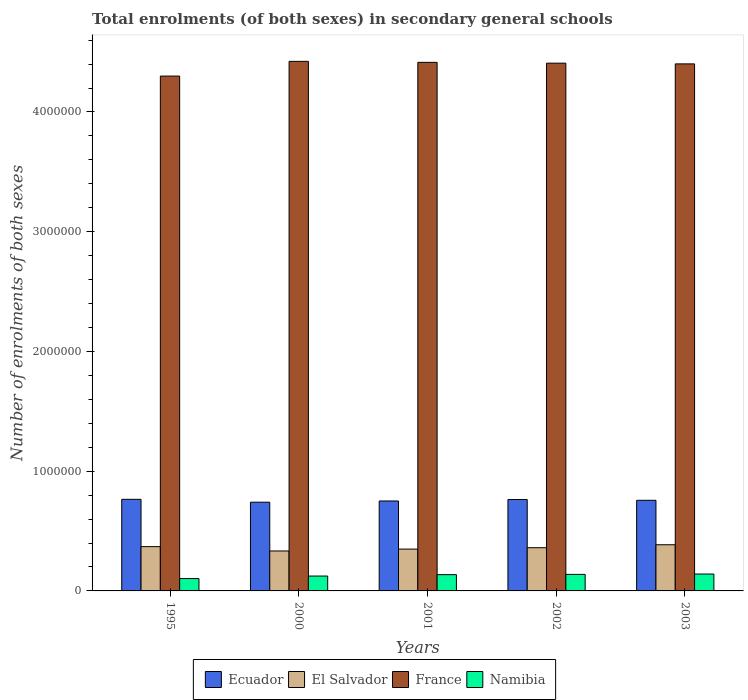How many groups of bars are there?
Ensure brevity in your answer.  5. Are the number of bars per tick equal to the number of legend labels?
Your answer should be very brief. Yes. Are the number of bars on each tick of the X-axis equal?
Provide a succinct answer. Yes. What is the label of the 5th group of bars from the left?
Make the answer very short. 2003. In how many cases, is the number of bars for a given year not equal to the number of legend labels?
Make the answer very short. 0. What is the number of enrolments in secondary schools in Namibia in 1995?
Keep it short and to the point. 1.03e+05. Across all years, what is the maximum number of enrolments in secondary schools in France?
Your answer should be compact. 4.42e+06. Across all years, what is the minimum number of enrolments in secondary schools in Namibia?
Give a very brief answer. 1.03e+05. What is the total number of enrolments in secondary schools in France in the graph?
Your answer should be compact. 2.19e+07. What is the difference between the number of enrolments in secondary schools in Ecuador in 1995 and that in 2003?
Provide a short and direct response. 8229. What is the difference between the number of enrolments in secondary schools in France in 2000 and the number of enrolments in secondary schools in Namibia in 2002?
Provide a succinct answer. 4.28e+06. What is the average number of enrolments in secondary schools in El Salvador per year?
Offer a terse response. 3.60e+05. In the year 1995, what is the difference between the number of enrolments in secondary schools in El Salvador and number of enrolments in secondary schools in Ecuador?
Ensure brevity in your answer.  -3.95e+05. In how many years, is the number of enrolments in secondary schools in El Salvador greater than 800000?
Offer a very short reply. 0. What is the ratio of the number of enrolments in secondary schools in France in 1995 to that in 2002?
Keep it short and to the point. 0.98. Is the number of enrolments in secondary schools in El Salvador in 1995 less than that in 2003?
Ensure brevity in your answer.  Yes. Is the difference between the number of enrolments in secondary schools in El Salvador in 1995 and 2000 greater than the difference between the number of enrolments in secondary schools in Ecuador in 1995 and 2000?
Offer a terse response. Yes. What is the difference between the highest and the second highest number of enrolments in secondary schools in El Salvador?
Give a very brief answer. 1.57e+04. What is the difference between the highest and the lowest number of enrolments in secondary schools in Ecuador?
Your answer should be compact. 2.40e+04. Is the sum of the number of enrolments in secondary schools in Namibia in 2000 and 2003 greater than the maximum number of enrolments in secondary schools in France across all years?
Make the answer very short. No. What does the 3rd bar from the left in 2002 represents?
Your response must be concise. France. What does the 4th bar from the right in 1995 represents?
Offer a very short reply. Ecuador. How many bars are there?
Keep it short and to the point. 20. How many years are there in the graph?
Provide a succinct answer. 5. What is the difference between two consecutive major ticks on the Y-axis?
Provide a succinct answer. 1.00e+06. Are the values on the major ticks of Y-axis written in scientific E-notation?
Offer a very short reply. No. Does the graph contain any zero values?
Your response must be concise. No. Does the graph contain grids?
Offer a terse response. No. What is the title of the graph?
Provide a short and direct response. Total enrolments (of both sexes) in secondary general schools. Does "Mauritania" appear as one of the legend labels in the graph?
Provide a succinct answer. No. What is the label or title of the Y-axis?
Offer a very short reply. Number of enrolments of both sexes. What is the Number of enrolments of both sexes of Ecuador in 1995?
Make the answer very short. 7.65e+05. What is the Number of enrolments of both sexes of El Salvador in 1995?
Offer a very short reply. 3.70e+05. What is the Number of enrolments of both sexes in France in 1995?
Your response must be concise. 4.30e+06. What is the Number of enrolments of both sexes in Namibia in 1995?
Give a very brief answer. 1.03e+05. What is the Number of enrolments of both sexes in Ecuador in 2000?
Provide a short and direct response. 7.41e+05. What is the Number of enrolments of both sexes of El Salvador in 2000?
Offer a terse response. 3.34e+05. What is the Number of enrolments of both sexes of France in 2000?
Provide a short and direct response. 4.42e+06. What is the Number of enrolments of both sexes in Namibia in 2000?
Keep it short and to the point. 1.24e+05. What is the Number of enrolments of both sexes in Ecuador in 2001?
Ensure brevity in your answer.  7.51e+05. What is the Number of enrolments of both sexes in El Salvador in 2001?
Provide a short and direct response. 3.49e+05. What is the Number of enrolments of both sexes in France in 2001?
Ensure brevity in your answer.  4.41e+06. What is the Number of enrolments of both sexes of Namibia in 2001?
Your answer should be compact. 1.36e+05. What is the Number of enrolments of both sexes of Ecuador in 2002?
Your response must be concise. 7.63e+05. What is the Number of enrolments of both sexes of El Salvador in 2002?
Make the answer very short. 3.61e+05. What is the Number of enrolments of both sexes in France in 2002?
Keep it short and to the point. 4.41e+06. What is the Number of enrolments of both sexes of Namibia in 2002?
Your answer should be very brief. 1.38e+05. What is the Number of enrolments of both sexes in Ecuador in 2003?
Give a very brief answer. 7.57e+05. What is the Number of enrolments of both sexes of El Salvador in 2003?
Make the answer very short. 3.86e+05. What is the Number of enrolments of both sexes in France in 2003?
Give a very brief answer. 4.40e+06. What is the Number of enrolments of both sexes in Namibia in 2003?
Keep it short and to the point. 1.41e+05. Across all years, what is the maximum Number of enrolments of both sexes of Ecuador?
Your response must be concise. 7.65e+05. Across all years, what is the maximum Number of enrolments of both sexes of El Salvador?
Offer a terse response. 3.86e+05. Across all years, what is the maximum Number of enrolments of both sexes of France?
Make the answer very short. 4.42e+06. Across all years, what is the maximum Number of enrolments of both sexes in Namibia?
Keep it short and to the point. 1.41e+05. Across all years, what is the minimum Number of enrolments of both sexes in Ecuador?
Your answer should be very brief. 7.41e+05. Across all years, what is the minimum Number of enrolments of both sexes of El Salvador?
Provide a short and direct response. 3.34e+05. Across all years, what is the minimum Number of enrolments of both sexes in France?
Your answer should be compact. 4.30e+06. Across all years, what is the minimum Number of enrolments of both sexes of Namibia?
Keep it short and to the point. 1.03e+05. What is the total Number of enrolments of both sexes in Ecuador in the graph?
Your answer should be compact. 3.78e+06. What is the total Number of enrolments of both sexes of El Salvador in the graph?
Make the answer very short. 1.80e+06. What is the total Number of enrolments of both sexes of France in the graph?
Offer a terse response. 2.19e+07. What is the total Number of enrolments of both sexes of Namibia in the graph?
Provide a succinct answer. 6.42e+05. What is the difference between the Number of enrolments of both sexes in Ecuador in 1995 and that in 2000?
Ensure brevity in your answer.  2.40e+04. What is the difference between the Number of enrolments of both sexes of El Salvador in 1995 and that in 2000?
Offer a terse response. 3.62e+04. What is the difference between the Number of enrolments of both sexes of France in 1995 and that in 2000?
Give a very brief answer. -1.23e+05. What is the difference between the Number of enrolments of both sexes in Namibia in 1995 and that in 2000?
Your answer should be compact. -2.10e+04. What is the difference between the Number of enrolments of both sexes of Ecuador in 1995 and that in 2001?
Make the answer very short. 1.38e+04. What is the difference between the Number of enrolments of both sexes in El Salvador in 1995 and that in 2001?
Keep it short and to the point. 2.05e+04. What is the difference between the Number of enrolments of both sexes of France in 1995 and that in 2001?
Offer a terse response. -1.15e+05. What is the difference between the Number of enrolments of both sexes in Namibia in 1995 and that in 2001?
Ensure brevity in your answer.  -3.27e+04. What is the difference between the Number of enrolments of both sexes of Ecuador in 1995 and that in 2002?
Provide a succinct answer. 1890. What is the difference between the Number of enrolments of both sexes of El Salvador in 1995 and that in 2002?
Offer a very short reply. 8955. What is the difference between the Number of enrolments of both sexes of France in 1995 and that in 2002?
Your answer should be very brief. -1.08e+05. What is the difference between the Number of enrolments of both sexes of Namibia in 1995 and that in 2002?
Offer a terse response. -3.49e+04. What is the difference between the Number of enrolments of both sexes of Ecuador in 1995 and that in 2003?
Your answer should be very brief. 8229. What is the difference between the Number of enrolments of both sexes in El Salvador in 1995 and that in 2003?
Offer a very short reply. -1.57e+04. What is the difference between the Number of enrolments of both sexes in France in 1995 and that in 2003?
Keep it short and to the point. -1.02e+05. What is the difference between the Number of enrolments of both sexes in Namibia in 1995 and that in 2003?
Give a very brief answer. -3.78e+04. What is the difference between the Number of enrolments of both sexes of Ecuador in 2000 and that in 2001?
Ensure brevity in your answer.  -1.02e+04. What is the difference between the Number of enrolments of both sexes of El Salvador in 2000 and that in 2001?
Provide a short and direct response. -1.57e+04. What is the difference between the Number of enrolments of both sexes of France in 2000 and that in 2001?
Make the answer very short. 8307. What is the difference between the Number of enrolments of both sexes in Namibia in 2000 and that in 2001?
Your answer should be very brief. -1.17e+04. What is the difference between the Number of enrolments of both sexes of Ecuador in 2000 and that in 2002?
Your answer should be very brief. -2.21e+04. What is the difference between the Number of enrolments of both sexes of El Salvador in 2000 and that in 2002?
Your response must be concise. -2.72e+04. What is the difference between the Number of enrolments of both sexes in France in 2000 and that in 2002?
Your response must be concise. 1.52e+04. What is the difference between the Number of enrolments of both sexes of Namibia in 2000 and that in 2002?
Make the answer very short. -1.39e+04. What is the difference between the Number of enrolments of both sexes of Ecuador in 2000 and that in 2003?
Make the answer very short. -1.58e+04. What is the difference between the Number of enrolments of both sexes in El Salvador in 2000 and that in 2003?
Provide a short and direct response. -5.19e+04. What is the difference between the Number of enrolments of both sexes in France in 2000 and that in 2003?
Your response must be concise. 2.11e+04. What is the difference between the Number of enrolments of both sexes in Namibia in 2000 and that in 2003?
Your answer should be very brief. -1.68e+04. What is the difference between the Number of enrolments of both sexes in Ecuador in 2001 and that in 2002?
Make the answer very short. -1.19e+04. What is the difference between the Number of enrolments of both sexes in El Salvador in 2001 and that in 2002?
Your response must be concise. -1.15e+04. What is the difference between the Number of enrolments of both sexes in France in 2001 and that in 2002?
Provide a short and direct response. 6854. What is the difference between the Number of enrolments of both sexes of Namibia in 2001 and that in 2002?
Provide a succinct answer. -2156. What is the difference between the Number of enrolments of both sexes of Ecuador in 2001 and that in 2003?
Your answer should be compact. -5604. What is the difference between the Number of enrolments of both sexes in El Salvador in 2001 and that in 2003?
Give a very brief answer. -3.62e+04. What is the difference between the Number of enrolments of both sexes of France in 2001 and that in 2003?
Keep it short and to the point. 1.28e+04. What is the difference between the Number of enrolments of both sexes in Namibia in 2001 and that in 2003?
Ensure brevity in your answer.  -5033. What is the difference between the Number of enrolments of both sexes in Ecuador in 2002 and that in 2003?
Keep it short and to the point. 6339. What is the difference between the Number of enrolments of both sexes of El Salvador in 2002 and that in 2003?
Your response must be concise. -2.46e+04. What is the difference between the Number of enrolments of both sexes in France in 2002 and that in 2003?
Give a very brief answer. 5914. What is the difference between the Number of enrolments of both sexes of Namibia in 2002 and that in 2003?
Provide a succinct answer. -2877. What is the difference between the Number of enrolments of both sexes in Ecuador in 1995 and the Number of enrolments of both sexes in El Salvador in 2000?
Provide a succinct answer. 4.31e+05. What is the difference between the Number of enrolments of both sexes in Ecuador in 1995 and the Number of enrolments of both sexes in France in 2000?
Offer a terse response. -3.66e+06. What is the difference between the Number of enrolments of both sexes in Ecuador in 1995 and the Number of enrolments of both sexes in Namibia in 2000?
Keep it short and to the point. 6.41e+05. What is the difference between the Number of enrolments of both sexes of El Salvador in 1995 and the Number of enrolments of both sexes of France in 2000?
Make the answer very short. -4.05e+06. What is the difference between the Number of enrolments of both sexes in El Salvador in 1995 and the Number of enrolments of both sexes in Namibia in 2000?
Ensure brevity in your answer.  2.46e+05. What is the difference between the Number of enrolments of both sexes of France in 1995 and the Number of enrolments of both sexes of Namibia in 2000?
Give a very brief answer. 4.18e+06. What is the difference between the Number of enrolments of both sexes in Ecuador in 1995 and the Number of enrolments of both sexes in El Salvador in 2001?
Make the answer very short. 4.16e+05. What is the difference between the Number of enrolments of both sexes in Ecuador in 1995 and the Number of enrolments of both sexes in France in 2001?
Give a very brief answer. -3.65e+06. What is the difference between the Number of enrolments of both sexes of Ecuador in 1995 and the Number of enrolments of both sexes of Namibia in 2001?
Ensure brevity in your answer.  6.29e+05. What is the difference between the Number of enrolments of both sexes in El Salvador in 1995 and the Number of enrolments of both sexes in France in 2001?
Provide a short and direct response. -4.04e+06. What is the difference between the Number of enrolments of both sexes in El Salvador in 1995 and the Number of enrolments of both sexes in Namibia in 2001?
Provide a succinct answer. 2.34e+05. What is the difference between the Number of enrolments of both sexes of France in 1995 and the Number of enrolments of both sexes of Namibia in 2001?
Your answer should be very brief. 4.16e+06. What is the difference between the Number of enrolments of both sexes in Ecuador in 1995 and the Number of enrolments of both sexes in El Salvador in 2002?
Your answer should be compact. 4.04e+05. What is the difference between the Number of enrolments of both sexes in Ecuador in 1995 and the Number of enrolments of both sexes in France in 2002?
Provide a succinct answer. -3.64e+06. What is the difference between the Number of enrolments of both sexes of Ecuador in 1995 and the Number of enrolments of both sexes of Namibia in 2002?
Offer a very short reply. 6.27e+05. What is the difference between the Number of enrolments of both sexes of El Salvador in 1995 and the Number of enrolments of both sexes of France in 2002?
Keep it short and to the point. -4.04e+06. What is the difference between the Number of enrolments of both sexes of El Salvador in 1995 and the Number of enrolments of both sexes of Namibia in 2002?
Your answer should be very brief. 2.32e+05. What is the difference between the Number of enrolments of both sexes in France in 1995 and the Number of enrolments of both sexes in Namibia in 2002?
Your answer should be very brief. 4.16e+06. What is the difference between the Number of enrolments of both sexes of Ecuador in 1995 and the Number of enrolments of both sexes of El Salvador in 2003?
Offer a terse response. 3.80e+05. What is the difference between the Number of enrolments of both sexes in Ecuador in 1995 and the Number of enrolments of both sexes in France in 2003?
Give a very brief answer. -3.64e+06. What is the difference between the Number of enrolments of both sexes in Ecuador in 1995 and the Number of enrolments of both sexes in Namibia in 2003?
Your answer should be compact. 6.24e+05. What is the difference between the Number of enrolments of both sexes of El Salvador in 1995 and the Number of enrolments of both sexes of France in 2003?
Give a very brief answer. -4.03e+06. What is the difference between the Number of enrolments of both sexes of El Salvador in 1995 and the Number of enrolments of both sexes of Namibia in 2003?
Your answer should be very brief. 2.29e+05. What is the difference between the Number of enrolments of both sexes of France in 1995 and the Number of enrolments of both sexes of Namibia in 2003?
Provide a succinct answer. 4.16e+06. What is the difference between the Number of enrolments of both sexes of Ecuador in 2000 and the Number of enrolments of both sexes of El Salvador in 2001?
Offer a very short reply. 3.92e+05. What is the difference between the Number of enrolments of both sexes in Ecuador in 2000 and the Number of enrolments of both sexes in France in 2001?
Your response must be concise. -3.67e+06. What is the difference between the Number of enrolments of both sexes in Ecuador in 2000 and the Number of enrolments of both sexes in Namibia in 2001?
Provide a short and direct response. 6.05e+05. What is the difference between the Number of enrolments of both sexes of El Salvador in 2000 and the Number of enrolments of both sexes of France in 2001?
Your answer should be compact. -4.08e+06. What is the difference between the Number of enrolments of both sexes in El Salvador in 2000 and the Number of enrolments of both sexes in Namibia in 2001?
Offer a terse response. 1.98e+05. What is the difference between the Number of enrolments of both sexes of France in 2000 and the Number of enrolments of both sexes of Namibia in 2001?
Provide a succinct answer. 4.29e+06. What is the difference between the Number of enrolments of both sexes of Ecuador in 2000 and the Number of enrolments of both sexes of El Salvador in 2002?
Your response must be concise. 3.80e+05. What is the difference between the Number of enrolments of both sexes of Ecuador in 2000 and the Number of enrolments of both sexes of France in 2002?
Provide a short and direct response. -3.67e+06. What is the difference between the Number of enrolments of both sexes of Ecuador in 2000 and the Number of enrolments of both sexes of Namibia in 2002?
Keep it short and to the point. 6.03e+05. What is the difference between the Number of enrolments of both sexes in El Salvador in 2000 and the Number of enrolments of both sexes in France in 2002?
Give a very brief answer. -4.07e+06. What is the difference between the Number of enrolments of both sexes in El Salvador in 2000 and the Number of enrolments of both sexes in Namibia in 2002?
Provide a succinct answer. 1.96e+05. What is the difference between the Number of enrolments of both sexes of France in 2000 and the Number of enrolments of both sexes of Namibia in 2002?
Your response must be concise. 4.28e+06. What is the difference between the Number of enrolments of both sexes in Ecuador in 2000 and the Number of enrolments of both sexes in El Salvador in 2003?
Your answer should be very brief. 3.56e+05. What is the difference between the Number of enrolments of both sexes of Ecuador in 2000 and the Number of enrolments of both sexes of France in 2003?
Your response must be concise. -3.66e+06. What is the difference between the Number of enrolments of both sexes of Ecuador in 2000 and the Number of enrolments of both sexes of Namibia in 2003?
Provide a succinct answer. 6.00e+05. What is the difference between the Number of enrolments of both sexes in El Salvador in 2000 and the Number of enrolments of both sexes in France in 2003?
Keep it short and to the point. -4.07e+06. What is the difference between the Number of enrolments of both sexes in El Salvador in 2000 and the Number of enrolments of both sexes in Namibia in 2003?
Offer a terse response. 1.93e+05. What is the difference between the Number of enrolments of both sexes in France in 2000 and the Number of enrolments of both sexes in Namibia in 2003?
Provide a succinct answer. 4.28e+06. What is the difference between the Number of enrolments of both sexes of Ecuador in 2001 and the Number of enrolments of both sexes of El Salvador in 2002?
Your response must be concise. 3.90e+05. What is the difference between the Number of enrolments of both sexes of Ecuador in 2001 and the Number of enrolments of both sexes of France in 2002?
Your answer should be compact. -3.66e+06. What is the difference between the Number of enrolments of both sexes in Ecuador in 2001 and the Number of enrolments of both sexes in Namibia in 2002?
Provide a succinct answer. 6.13e+05. What is the difference between the Number of enrolments of both sexes of El Salvador in 2001 and the Number of enrolments of both sexes of France in 2002?
Keep it short and to the point. -4.06e+06. What is the difference between the Number of enrolments of both sexes of El Salvador in 2001 and the Number of enrolments of both sexes of Namibia in 2002?
Ensure brevity in your answer.  2.11e+05. What is the difference between the Number of enrolments of both sexes in France in 2001 and the Number of enrolments of both sexes in Namibia in 2002?
Provide a succinct answer. 4.28e+06. What is the difference between the Number of enrolments of both sexes of Ecuador in 2001 and the Number of enrolments of both sexes of El Salvador in 2003?
Make the answer very short. 3.66e+05. What is the difference between the Number of enrolments of both sexes in Ecuador in 2001 and the Number of enrolments of both sexes in France in 2003?
Offer a very short reply. -3.65e+06. What is the difference between the Number of enrolments of both sexes in Ecuador in 2001 and the Number of enrolments of both sexes in Namibia in 2003?
Provide a short and direct response. 6.10e+05. What is the difference between the Number of enrolments of both sexes of El Salvador in 2001 and the Number of enrolments of both sexes of France in 2003?
Offer a very short reply. -4.05e+06. What is the difference between the Number of enrolments of both sexes of El Salvador in 2001 and the Number of enrolments of both sexes of Namibia in 2003?
Provide a succinct answer. 2.08e+05. What is the difference between the Number of enrolments of both sexes of France in 2001 and the Number of enrolments of both sexes of Namibia in 2003?
Keep it short and to the point. 4.27e+06. What is the difference between the Number of enrolments of both sexes in Ecuador in 2002 and the Number of enrolments of both sexes in El Salvador in 2003?
Provide a short and direct response. 3.78e+05. What is the difference between the Number of enrolments of both sexes of Ecuador in 2002 and the Number of enrolments of both sexes of France in 2003?
Ensure brevity in your answer.  -3.64e+06. What is the difference between the Number of enrolments of both sexes of Ecuador in 2002 and the Number of enrolments of both sexes of Namibia in 2003?
Keep it short and to the point. 6.22e+05. What is the difference between the Number of enrolments of both sexes of El Salvador in 2002 and the Number of enrolments of both sexes of France in 2003?
Your answer should be compact. -4.04e+06. What is the difference between the Number of enrolments of both sexes in El Salvador in 2002 and the Number of enrolments of both sexes in Namibia in 2003?
Offer a very short reply. 2.20e+05. What is the difference between the Number of enrolments of both sexes of France in 2002 and the Number of enrolments of both sexes of Namibia in 2003?
Offer a very short reply. 4.27e+06. What is the average Number of enrolments of both sexes in Ecuador per year?
Give a very brief answer. 7.55e+05. What is the average Number of enrolments of both sexes of El Salvador per year?
Keep it short and to the point. 3.60e+05. What is the average Number of enrolments of both sexes of France per year?
Offer a very short reply. 4.39e+06. What is the average Number of enrolments of both sexes in Namibia per year?
Offer a terse response. 1.28e+05. In the year 1995, what is the difference between the Number of enrolments of both sexes of Ecuador and Number of enrolments of both sexes of El Salvador?
Make the answer very short. 3.95e+05. In the year 1995, what is the difference between the Number of enrolments of both sexes of Ecuador and Number of enrolments of both sexes of France?
Offer a very short reply. -3.53e+06. In the year 1995, what is the difference between the Number of enrolments of both sexes in Ecuador and Number of enrolments of both sexes in Namibia?
Ensure brevity in your answer.  6.62e+05. In the year 1995, what is the difference between the Number of enrolments of both sexes in El Salvador and Number of enrolments of both sexes in France?
Ensure brevity in your answer.  -3.93e+06. In the year 1995, what is the difference between the Number of enrolments of both sexes of El Salvador and Number of enrolments of both sexes of Namibia?
Your response must be concise. 2.67e+05. In the year 1995, what is the difference between the Number of enrolments of both sexes in France and Number of enrolments of both sexes in Namibia?
Offer a terse response. 4.20e+06. In the year 2000, what is the difference between the Number of enrolments of both sexes of Ecuador and Number of enrolments of both sexes of El Salvador?
Your answer should be very brief. 4.07e+05. In the year 2000, what is the difference between the Number of enrolments of both sexes of Ecuador and Number of enrolments of both sexes of France?
Make the answer very short. -3.68e+06. In the year 2000, what is the difference between the Number of enrolments of both sexes in Ecuador and Number of enrolments of both sexes in Namibia?
Your answer should be compact. 6.17e+05. In the year 2000, what is the difference between the Number of enrolments of both sexes of El Salvador and Number of enrolments of both sexes of France?
Give a very brief answer. -4.09e+06. In the year 2000, what is the difference between the Number of enrolments of both sexes of El Salvador and Number of enrolments of both sexes of Namibia?
Your answer should be compact. 2.09e+05. In the year 2000, what is the difference between the Number of enrolments of both sexes of France and Number of enrolments of both sexes of Namibia?
Your answer should be compact. 4.30e+06. In the year 2001, what is the difference between the Number of enrolments of both sexes of Ecuador and Number of enrolments of both sexes of El Salvador?
Keep it short and to the point. 4.02e+05. In the year 2001, what is the difference between the Number of enrolments of both sexes in Ecuador and Number of enrolments of both sexes in France?
Keep it short and to the point. -3.66e+06. In the year 2001, what is the difference between the Number of enrolments of both sexes in Ecuador and Number of enrolments of both sexes in Namibia?
Your answer should be very brief. 6.15e+05. In the year 2001, what is the difference between the Number of enrolments of both sexes in El Salvador and Number of enrolments of both sexes in France?
Ensure brevity in your answer.  -4.07e+06. In the year 2001, what is the difference between the Number of enrolments of both sexes in El Salvador and Number of enrolments of both sexes in Namibia?
Keep it short and to the point. 2.13e+05. In the year 2001, what is the difference between the Number of enrolments of both sexes of France and Number of enrolments of both sexes of Namibia?
Offer a terse response. 4.28e+06. In the year 2002, what is the difference between the Number of enrolments of both sexes in Ecuador and Number of enrolments of both sexes in El Salvador?
Offer a terse response. 4.02e+05. In the year 2002, what is the difference between the Number of enrolments of both sexes in Ecuador and Number of enrolments of both sexes in France?
Provide a short and direct response. -3.64e+06. In the year 2002, what is the difference between the Number of enrolments of both sexes of Ecuador and Number of enrolments of both sexes of Namibia?
Your response must be concise. 6.25e+05. In the year 2002, what is the difference between the Number of enrolments of both sexes in El Salvador and Number of enrolments of both sexes in France?
Give a very brief answer. -4.05e+06. In the year 2002, what is the difference between the Number of enrolments of both sexes of El Salvador and Number of enrolments of both sexes of Namibia?
Your answer should be compact. 2.23e+05. In the year 2002, what is the difference between the Number of enrolments of both sexes of France and Number of enrolments of both sexes of Namibia?
Your response must be concise. 4.27e+06. In the year 2003, what is the difference between the Number of enrolments of both sexes of Ecuador and Number of enrolments of both sexes of El Salvador?
Your response must be concise. 3.71e+05. In the year 2003, what is the difference between the Number of enrolments of both sexes in Ecuador and Number of enrolments of both sexes in France?
Offer a very short reply. -3.65e+06. In the year 2003, what is the difference between the Number of enrolments of both sexes in Ecuador and Number of enrolments of both sexes in Namibia?
Provide a succinct answer. 6.16e+05. In the year 2003, what is the difference between the Number of enrolments of both sexes of El Salvador and Number of enrolments of both sexes of France?
Provide a succinct answer. -4.02e+06. In the year 2003, what is the difference between the Number of enrolments of both sexes in El Salvador and Number of enrolments of both sexes in Namibia?
Provide a succinct answer. 2.45e+05. In the year 2003, what is the difference between the Number of enrolments of both sexes in France and Number of enrolments of both sexes in Namibia?
Offer a terse response. 4.26e+06. What is the ratio of the Number of enrolments of both sexes of Ecuador in 1995 to that in 2000?
Your response must be concise. 1.03. What is the ratio of the Number of enrolments of both sexes of El Salvador in 1995 to that in 2000?
Keep it short and to the point. 1.11. What is the ratio of the Number of enrolments of both sexes in France in 1995 to that in 2000?
Provide a short and direct response. 0.97. What is the ratio of the Number of enrolments of both sexes in Namibia in 1995 to that in 2000?
Give a very brief answer. 0.83. What is the ratio of the Number of enrolments of both sexes in Ecuador in 1995 to that in 2001?
Offer a very short reply. 1.02. What is the ratio of the Number of enrolments of both sexes in El Salvador in 1995 to that in 2001?
Offer a very short reply. 1.06. What is the ratio of the Number of enrolments of both sexes in France in 1995 to that in 2001?
Your response must be concise. 0.97. What is the ratio of the Number of enrolments of both sexes of Namibia in 1995 to that in 2001?
Give a very brief answer. 0.76. What is the ratio of the Number of enrolments of both sexes in Ecuador in 1995 to that in 2002?
Offer a terse response. 1. What is the ratio of the Number of enrolments of both sexes in El Salvador in 1995 to that in 2002?
Your response must be concise. 1.02. What is the ratio of the Number of enrolments of both sexes of France in 1995 to that in 2002?
Ensure brevity in your answer.  0.98. What is the ratio of the Number of enrolments of both sexes of Namibia in 1995 to that in 2002?
Your answer should be compact. 0.75. What is the ratio of the Number of enrolments of both sexes of Ecuador in 1995 to that in 2003?
Make the answer very short. 1.01. What is the ratio of the Number of enrolments of both sexes in El Salvador in 1995 to that in 2003?
Your answer should be very brief. 0.96. What is the ratio of the Number of enrolments of both sexes in France in 1995 to that in 2003?
Provide a short and direct response. 0.98. What is the ratio of the Number of enrolments of both sexes in Namibia in 1995 to that in 2003?
Your answer should be compact. 0.73. What is the ratio of the Number of enrolments of both sexes in Ecuador in 2000 to that in 2001?
Make the answer very short. 0.99. What is the ratio of the Number of enrolments of both sexes in El Salvador in 2000 to that in 2001?
Your answer should be compact. 0.96. What is the ratio of the Number of enrolments of both sexes of France in 2000 to that in 2001?
Ensure brevity in your answer.  1. What is the ratio of the Number of enrolments of both sexes of Namibia in 2000 to that in 2001?
Your answer should be compact. 0.91. What is the ratio of the Number of enrolments of both sexes of Ecuador in 2000 to that in 2002?
Offer a terse response. 0.97. What is the ratio of the Number of enrolments of both sexes in El Salvador in 2000 to that in 2002?
Offer a terse response. 0.92. What is the ratio of the Number of enrolments of both sexes in Namibia in 2000 to that in 2002?
Offer a very short reply. 0.9. What is the ratio of the Number of enrolments of both sexes in Ecuador in 2000 to that in 2003?
Keep it short and to the point. 0.98. What is the ratio of the Number of enrolments of both sexes of El Salvador in 2000 to that in 2003?
Your response must be concise. 0.87. What is the ratio of the Number of enrolments of both sexes in France in 2000 to that in 2003?
Provide a short and direct response. 1. What is the ratio of the Number of enrolments of both sexes in Namibia in 2000 to that in 2003?
Keep it short and to the point. 0.88. What is the ratio of the Number of enrolments of both sexes in Ecuador in 2001 to that in 2002?
Offer a very short reply. 0.98. What is the ratio of the Number of enrolments of both sexes of Namibia in 2001 to that in 2002?
Make the answer very short. 0.98. What is the ratio of the Number of enrolments of both sexes of Ecuador in 2001 to that in 2003?
Your answer should be compact. 0.99. What is the ratio of the Number of enrolments of both sexes of El Salvador in 2001 to that in 2003?
Offer a very short reply. 0.91. What is the ratio of the Number of enrolments of both sexes in Namibia in 2001 to that in 2003?
Your answer should be very brief. 0.96. What is the ratio of the Number of enrolments of both sexes in Ecuador in 2002 to that in 2003?
Your answer should be very brief. 1.01. What is the ratio of the Number of enrolments of both sexes of El Salvador in 2002 to that in 2003?
Make the answer very short. 0.94. What is the ratio of the Number of enrolments of both sexes of Namibia in 2002 to that in 2003?
Keep it short and to the point. 0.98. What is the difference between the highest and the second highest Number of enrolments of both sexes of Ecuador?
Offer a terse response. 1890. What is the difference between the highest and the second highest Number of enrolments of both sexes in El Salvador?
Provide a short and direct response. 1.57e+04. What is the difference between the highest and the second highest Number of enrolments of both sexes of France?
Your response must be concise. 8307. What is the difference between the highest and the second highest Number of enrolments of both sexes of Namibia?
Make the answer very short. 2877. What is the difference between the highest and the lowest Number of enrolments of both sexes in Ecuador?
Your answer should be compact. 2.40e+04. What is the difference between the highest and the lowest Number of enrolments of both sexes of El Salvador?
Offer a terse response. 5.19e+04. What is the difference between the highest and the lowest Number of enrolments of both sexes in France?
Give a very brief answer. 1.23e+05. What is the difference between the highest and the lowest Number of enrolments of both sexes in Namibia?
Your answer should be very brief. 3.78e+04. 